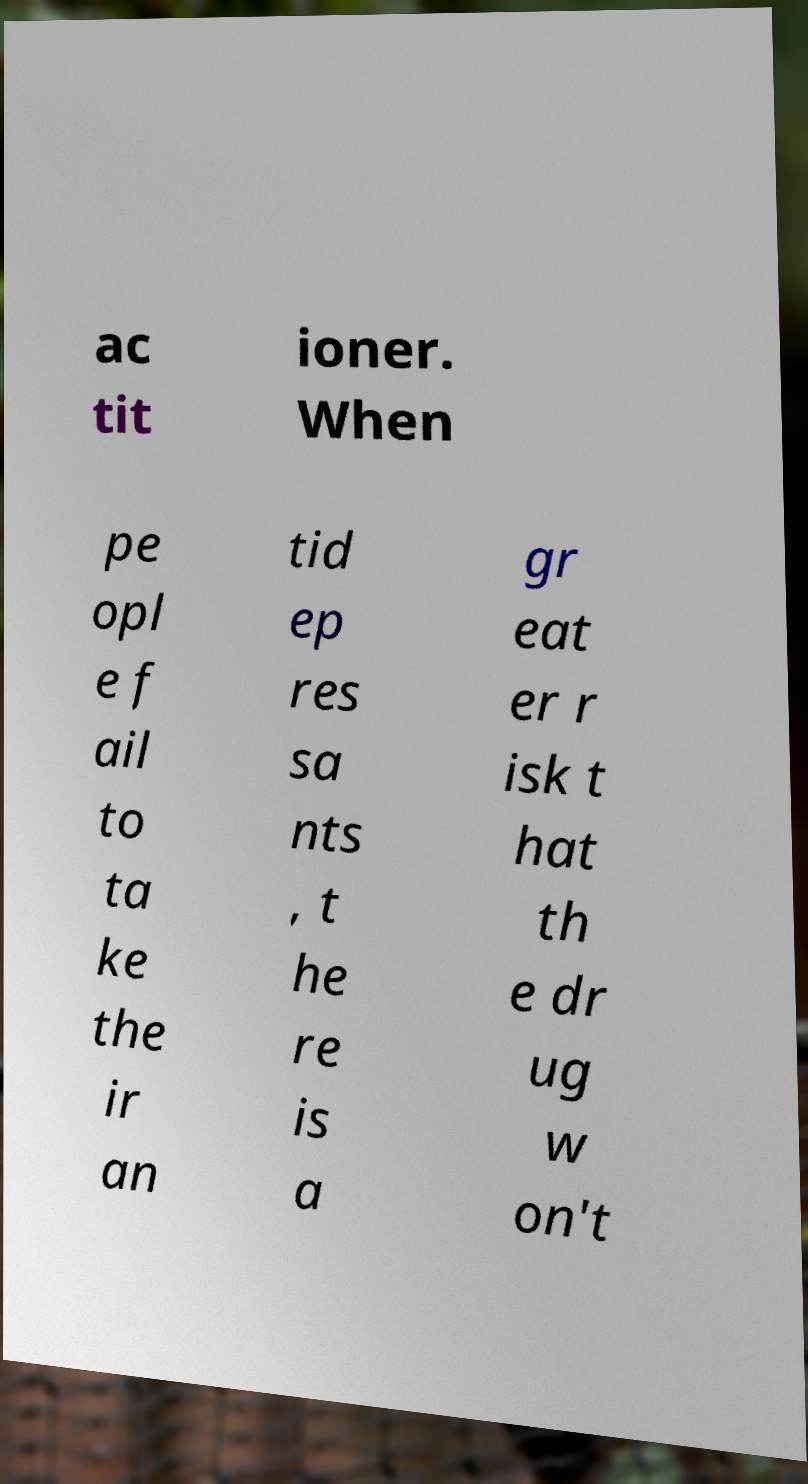Could you extract and type out the text from this image? ac tit ioner. When pe opl e f ail to ta ke the ir an tid ep res sa nts , t he re is a gr eat er r isk t hat th e dr ug w on't 